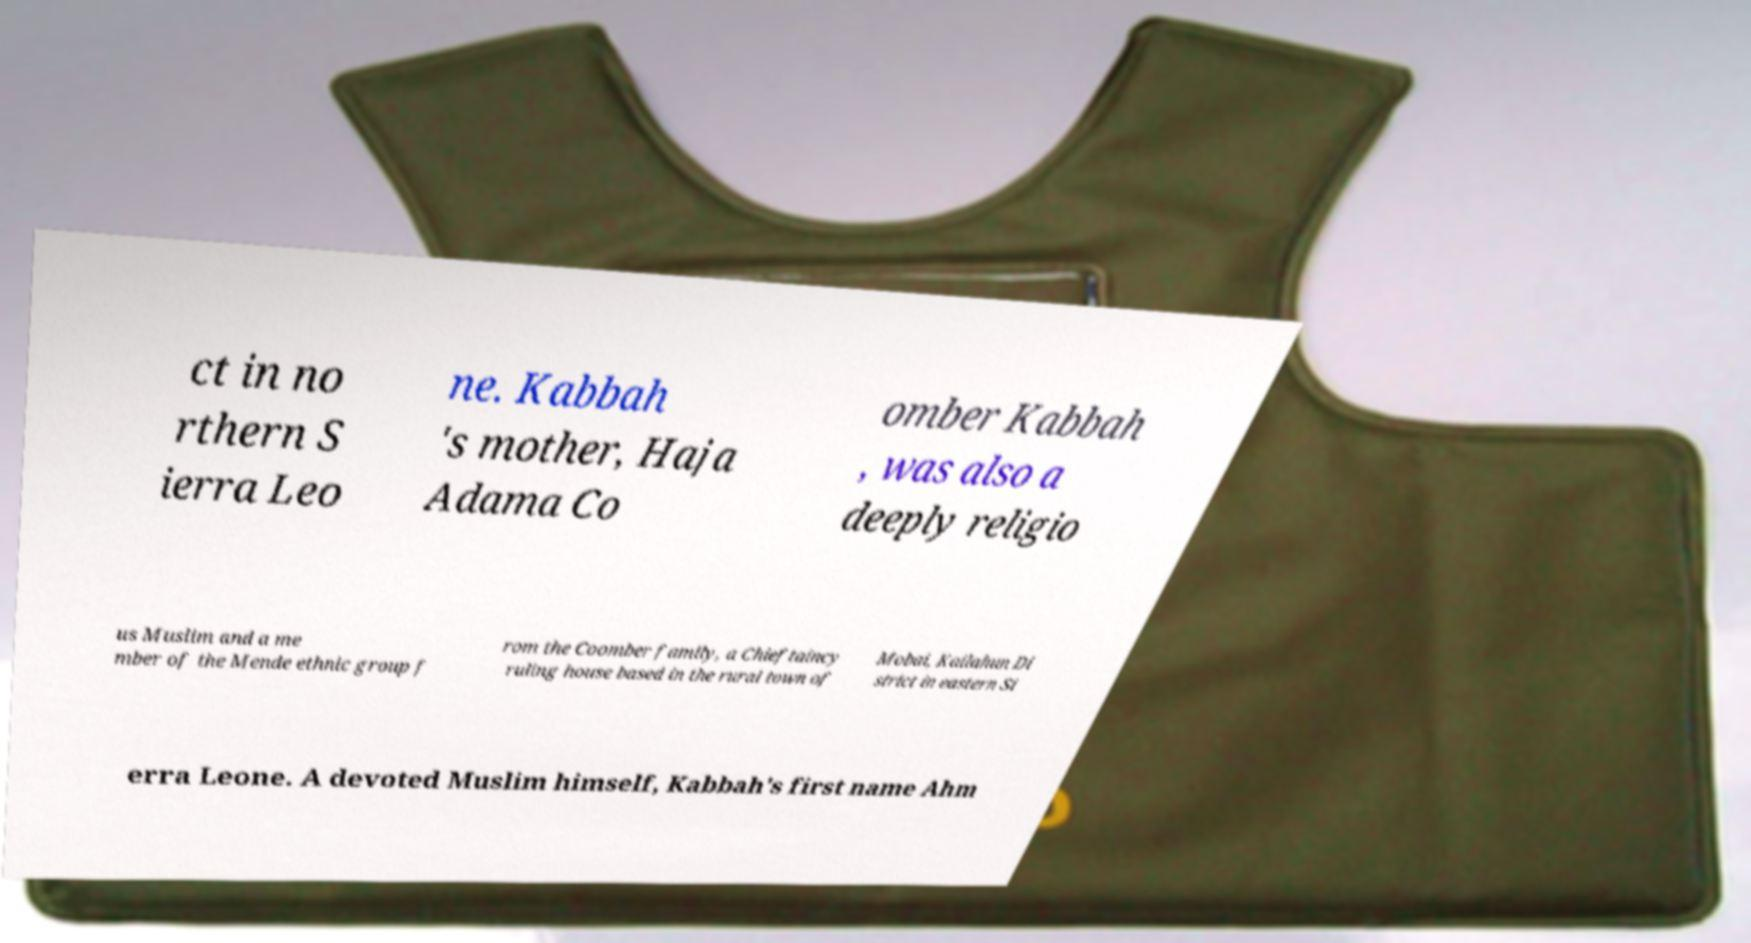For documentation purposes, I need the text within this image transcribed. Could you provide that? ct in no rthern S ierra Leo ne. Kabbah 's mother, Haja Adama Co omber Kabbah , was also a deeply religio us Muslim and a me mber of the Mende ethnic group f rom the Coomber family, a Chieftaincy ruling house based in the rural town of Mobai, Kailahun Di strict in eastern Si erra Leone. A devoted Muslim himself, Kabbah's first name Ahm 